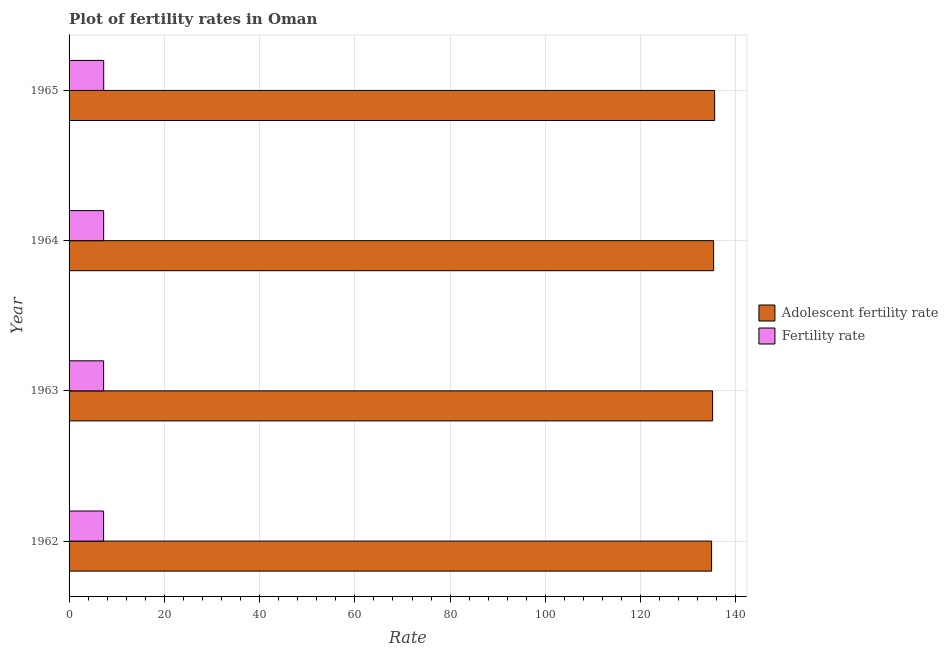How many different coloured bars are there?
Make the answer very short. 2. How many groups of bars are there?
Provide a short and direct response. 4. Are the number of bars on each tick of the Y-axis equal?
Keep it short and to the point. Yes. How many bars are there on the 1st tick from the top?
Offer a very short reply. 2. How many bars are there on the 2nd tick from the bottom?
Provide a succinct answer. 2. What is the adolescent fertility rate in 1962?
Provide a succinct answer. 134.9. Across all years, what is the maximum fertility rate?
Provide a short and direct response. 7.27. Across all years, what is the minimum fertility rate?
Make the answer very short. 7.25. In which year was the fertility rate maximum?
Ensure brevity in your answer.  1965. What is the total adolescent fertility rate in the graph?
Provide a short and direct response. 540.89. What is the difference between the fertility rate in 1962 and that in 1963?
Keep it short and to the point. -0.01. What is the difference between the adolescent fertility rate in 1962 and the fertility rate in 1964?
Make the answer very short. 127.64. What is the average adolescent fertility rate per year?
Your response must be concise. 135.22. In the year 1964, what is the difference between the adolescent fertility rate and fertility rate?
Provide a short and direct response. 128.06. In how many years, is the adolescent fertility rate greater than 124 ?
Offer a terse response. 4. What is the ratio of the fertility rate in 1962 to that in 1965?
Keep it short and to the point. 1. Is the fertility rate in 1964 less than that in 1965?
Your response must be concise. Yes. Is the difference between the adolescent fertility rate in 1964 and 1965 greater than the difference between the fertility rate in 1964 and 1965?
Provide a succinct answer. No. What is the difference between the highest and the second highest adolescent fertility rate?
Your response must be concise. 0.21. In how many years, is the fertility rate greater than the average fertility rate taken over all years?
Offer a terse response. 2. Is the sum of the adolescent fertility rate in 1963 and 1964 greater than the maximum fertility rate across all years?
Keep it short and to the point. Yes. What does the 2nd bar from the top in 1963 represents?
Your response must be concise. Adolescent fertility rate. What does the 1st bar from the bottom in 1962 represents?
Keep it short and to the point. Adolescent fertility rate. How many years are there in the graph?
Your answer should be very brief. 4. What is the difference between two consecutive major ticks on the X-axis?
Give a very brief answer. 20. Are the values on the major ticks of X-axis written in scientific E-notation?
Provide a succinct answer. No. What is the title of the graph?
Provide a succinct answer. Plot of fertility rates in Oman. Does "Under-5(male)" appear as one of the legend labels in the graph?
Offer a terse response. No. What is the label or title of the X-axis?
Your response must be concise. Rate. What is the Rate in Adolescent fertility rate in 1962?
Offer a terse response. 134.9. What is the Rate of Fertility rate in 1962?
Your answer should be very brief. 7.25. What is the Rate of Adolescent fertility rate in 1963?
Your response must be concise. 135.12. What is the Rate in Fertility rate in 1963?
Ensure brevity in your answer.  7.26. What is the Rate of Adolescent fertility rate in 1964?
Make the answer very short. 135.33. What is the Rate of Fertility rate in 1964?
Offer a terse response. 7.26. What is the Rate in Adolescent fertility rate in 1965?
Offer a terse response. 135.54. What is the Rate in Fertility rate in 1965?
Your answer should be very brief. 7.27. Across all years, what is the maximum Rate of Adolescent fertility rate?
Keep it short and to the point. 135.54. Across all years, what is the maximum Rate of Fertility rate?
Your answer should be very brief. 7.27. Across all years, what is the minimum Rate of Adolescent fertility rate?
Provide a short and direct response. 134.9. Across all years, what is the minimum Rate in Fertility rate?
Your answer should be very brief. 7.25. What is the total Rate in Adolescent fertility rate in the graph?
Provide a succinct answer. 540.89. What is the total Rate of Fertility rate in the graph?
Offer a terse response. 29.04. What is the difference between the Rate of Adolescent fertility rate in 1962 and that in 1963?
Provide a short and direct response. -0.21. What is the difference between the Rate in Fertility rate in 1962 and that in 1963?
Your response must be concise. -0.01. What is the difference between the Rate of Adolescent fertility rate in 1962 and that in 1964?
Your answer should be very brief. -0.42. What is the difference between the Rate of Fertility rate in 1962 and that in 1964?
Your answer should be very brief. -0.01. What is the difference between the Rate in Adolescent fertility rate in 1962 and that in 1965?
Your answer should be compact. -0.64. What is the difference between the Rate of Fertility rate in 1962 and that in 1965?
Provide a short and direct response. -0.02. What is the difference between the Rate in Adolescent fertility rate in 1963 and that in 1964?
Keep it short and to the point. -0.21. What is the difference between the Rate of Fertility rate in 1963 and that in 1964?
Your answer should be very brief. -0.01. What is the difference between the Rate of Adolescent fertility rate in 1963 and that in 1965?
Provide a short and direct response. -0.42. What is the difference between the Rate of Fertility rate in 1963 and that in 1965?
Offer a very short reply. -0.01. What is the difference between the Rate in Adolescent fertility rate in 1964 and that in 1965?
Provide a succinct answer. -0.21. What is the difference between the Rate of Fertility rate in 1964 and that in 1965?
Your answer should be compact. -0.01. What is the difference between the Rate of Adolescent fertility rate in 1962 and the Rate of Fertility rate in 1963?
Provide a short and direct response. 127.65. What is the difference between the Rate in Adolescent fertility rate in 1962 and the Rate in Fertility rate in 1964?
Ensure brevity in your answer.  127.64. What is the difference between the Rate of Adolescent fertility rate in 1962 and the Rate of Fertility rate in 1965?
Your answer should be compact. 127.63. What is the difference between the Rate in Adolescent fertility rate in 1963 and the Rate in Fertility rate in 1964?
Give a very brief answer. 127.85. What is the difference between the Rate of Adolescent fertility rate in 1963 and the Rate of Fertility rate in 1965?
Ensure brevity in your answer.  127.84. What is the difference between the Rate in Adolescent fertility rate in 1964 and the Rate in Fertility rate in 1965?
Give a very brief answer. 128.06. What is the average Rate of Adolescent fertility rate per year?
Your answer should be compact. 135.22. What is the average Rate of Fertility rate per year?
Give a very brief answer. 7.26. In the year 1962, what is the difference between the Rate of Adolescent fertility rate and Rate of Fertility rate?
Provide a succinct answer. 127.65. In the year 1963, what is the difference between the Rate of Adolescent fertility rate and Rate of Fertility rate?
Your response must be concise. 127.86. In the year 1964, what is the difference between the Rate of Adolescent fertility rate and Rate of Fertility rate?
Offer a terse response. 128.06. In the year 1965, what is the difference between the Rate in Adolescent fertility rate and Rate in Fertility rate?
Keep it short and to the point. 128.27. What is the ratio of the Rate of Adolescent fertility rate in 1962 to that in 1963?
Ensure brevity in your answer.  1. What is the ratio of the Rate of Fertility rate in 1962 to that in 1963?
Provide a short and direct response. 1. What is the ratio of the Rate in Fertility rate in 1962 to that in 1964?
Offer a terse response. 1. What is the ratio of the Rate in Adolescent fertility rate in 1962 to that in 1965?
Offer a terse response. 1. What is the ratio of the Rate of Fertility rate in 1962 to that in 1965?
Provide a short and direct response. 1. What is the ratio of the Rate in Adolescent fertility rate in 1963 to that in 1964?
Keep it short and to the point. 1. What is the ratio of the Rate of Adolescent fertility rate in 1963 to that in 1965?
Make the answer very short. 1. What is the ratio of the Rate of Adolescent fertility rate in 1964 to that in 1965?
Keep it short and to the point. 1. What is the difference between the highest and the second highest Rate in Adolescent fertility rate?
Offer a very short reply. 0.21. What is the difference between the highest and the second highest Rate of Fertility rate?
Your answer should be very brief. 0.01. What is the difference between the highest and the lowest Rate of Adolescent fertility rate?
Provide a short and direct response. 0.64. 